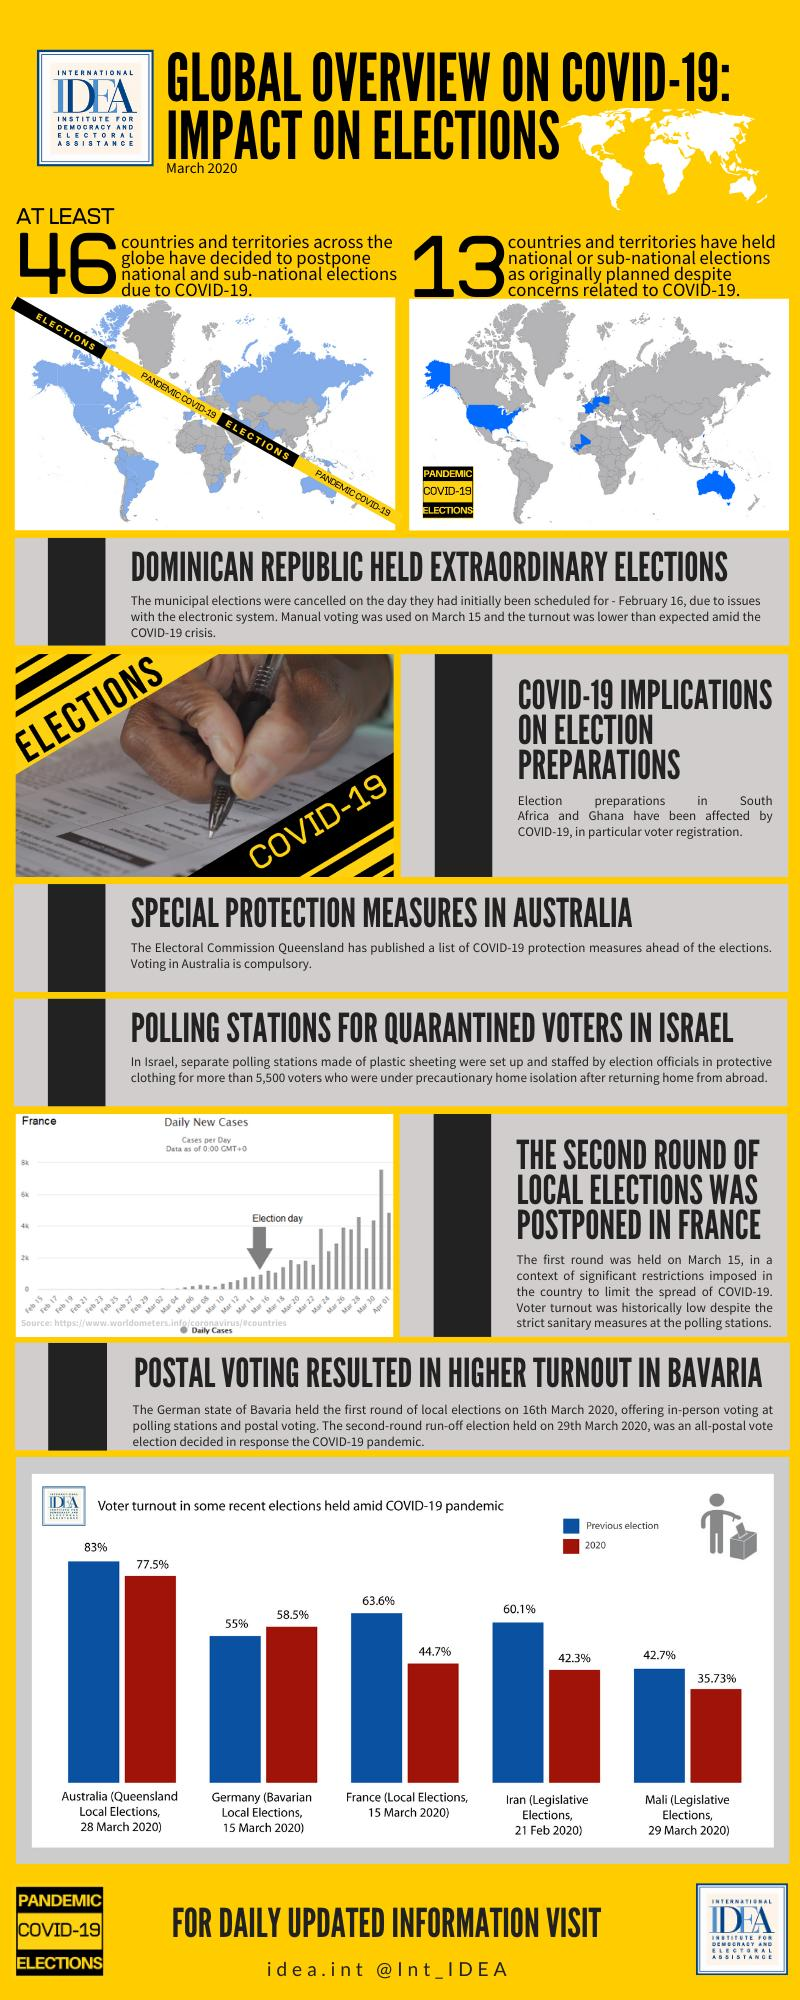Highlight a few significant elements in this photo. The voter turnout in the legislative elections of Mali on March 29, 2020 was 35.73%. The voter turnout in the previous legislative elections of Iran was 60.1%. The voter turnout in the local elections of France on March 15, 2020, was 44.7%. 